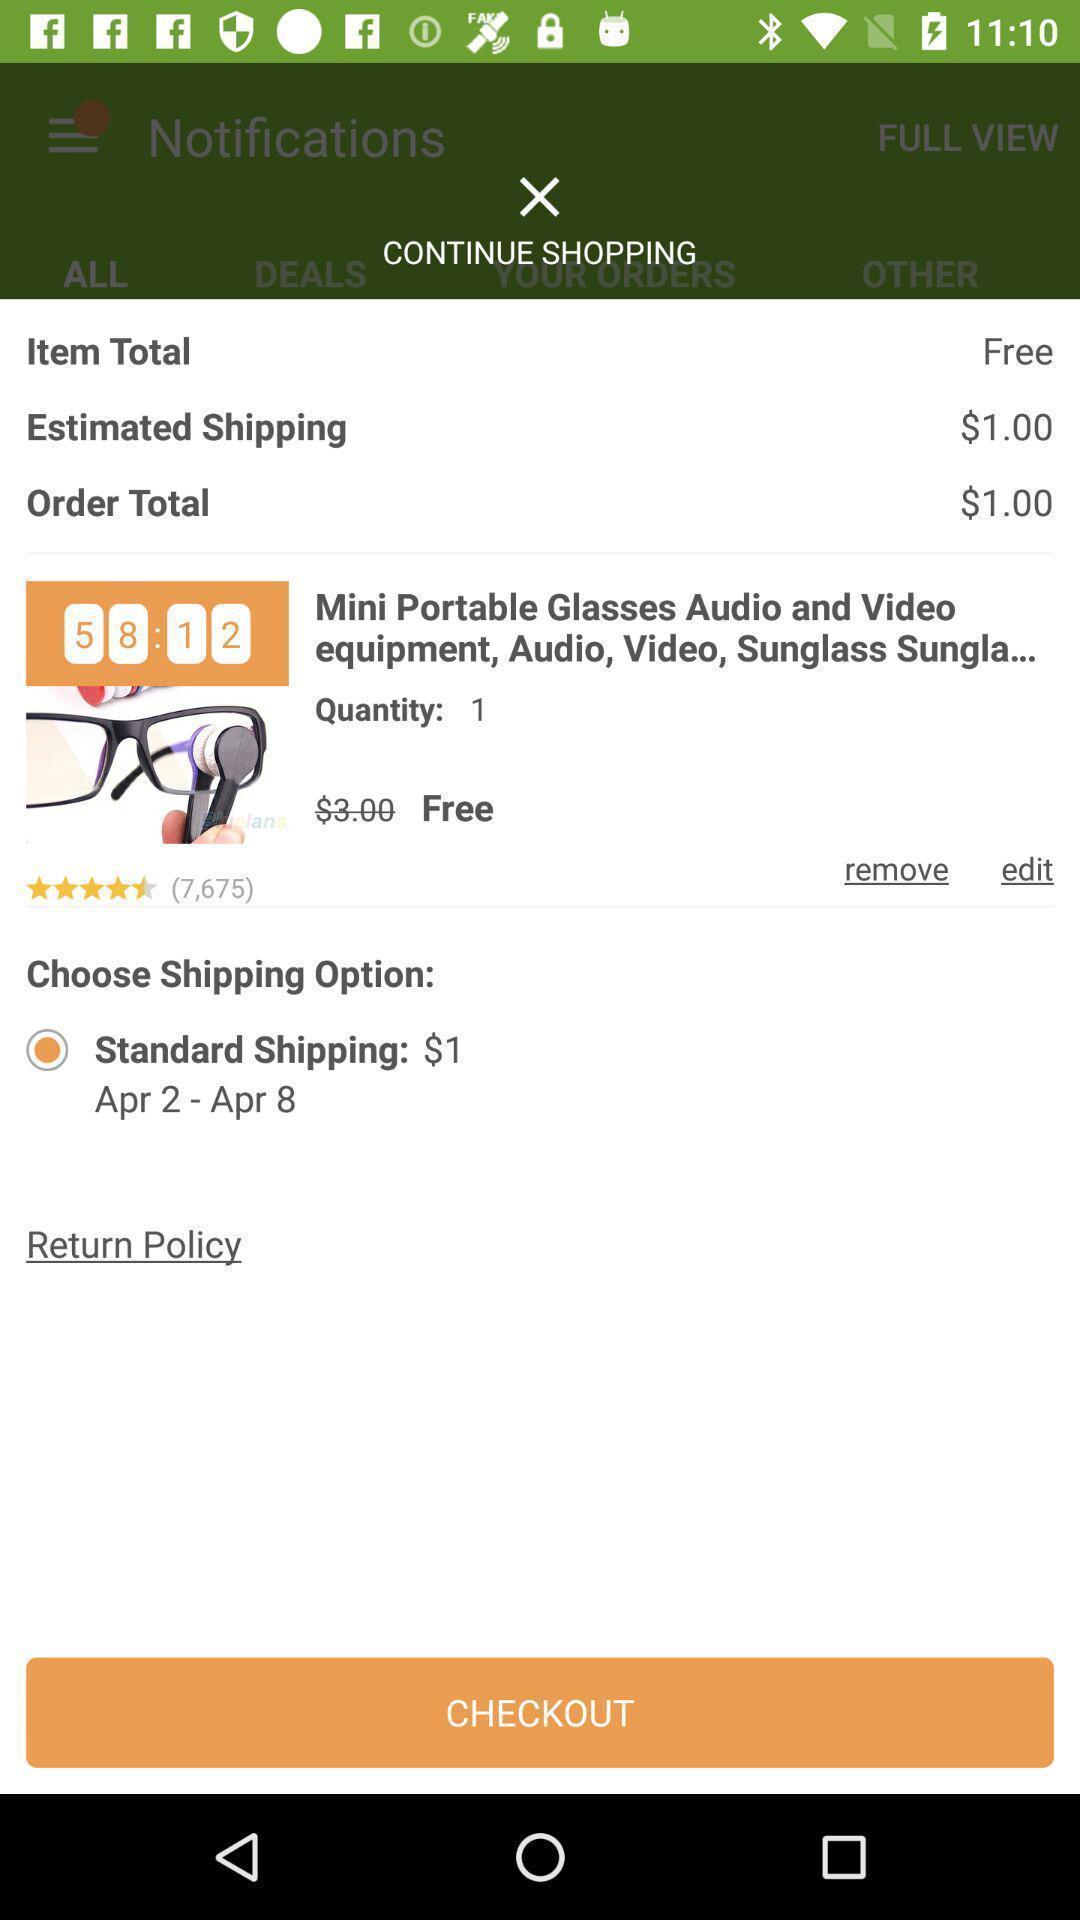Give me a summary of this screen capture. Shipping option page in a shopping app. 